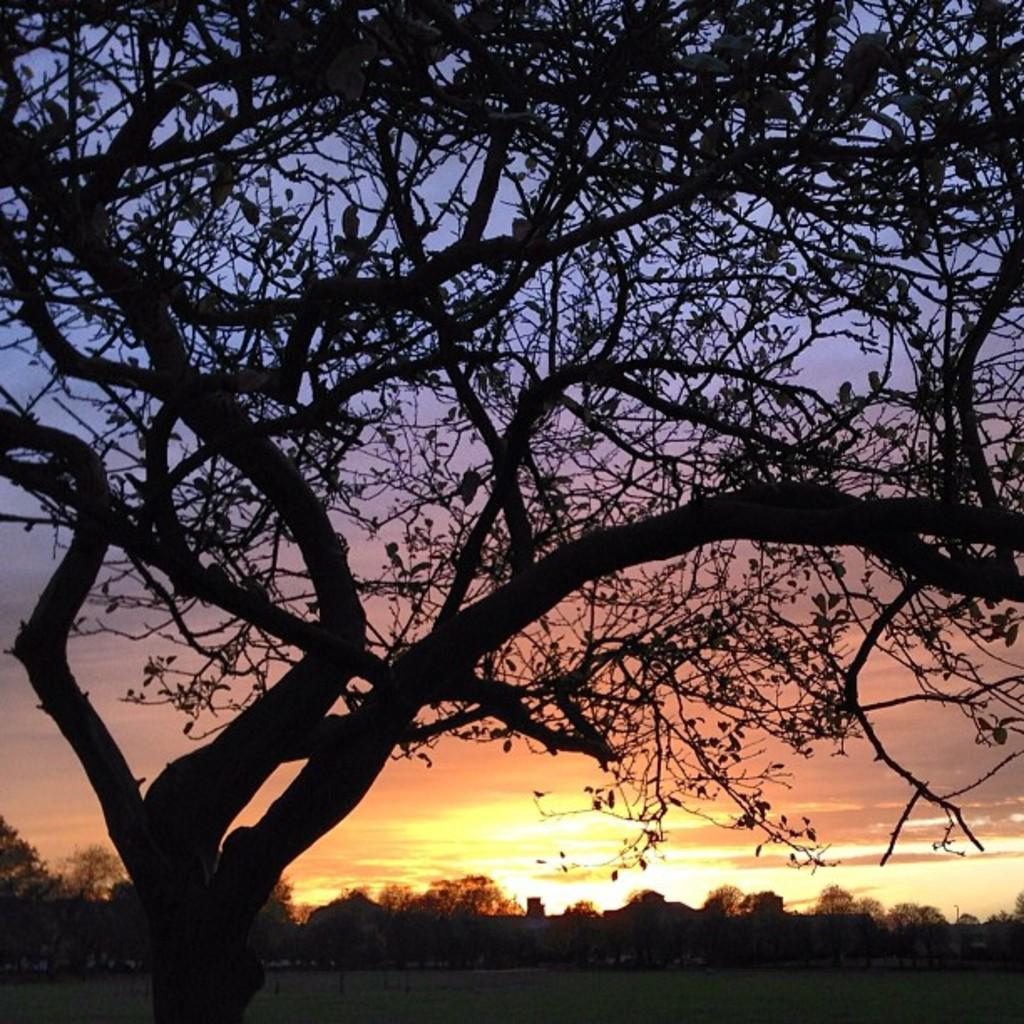What type of vegetation can be seen in the image? There are trees in the image. What else can be seen on the ground in the image? There is grass in the image. What is visible in the background of the image? The sky is visible in the background of the image. What type of doctor can be seen attending to the trees in the image? There is no doctor present in the image, and the trees do not require medical attention. 